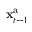<formula> <loc_0><loc_0><loc_500><loc_500>{ x } _ { t - 1 } ^ { a }</formula> 